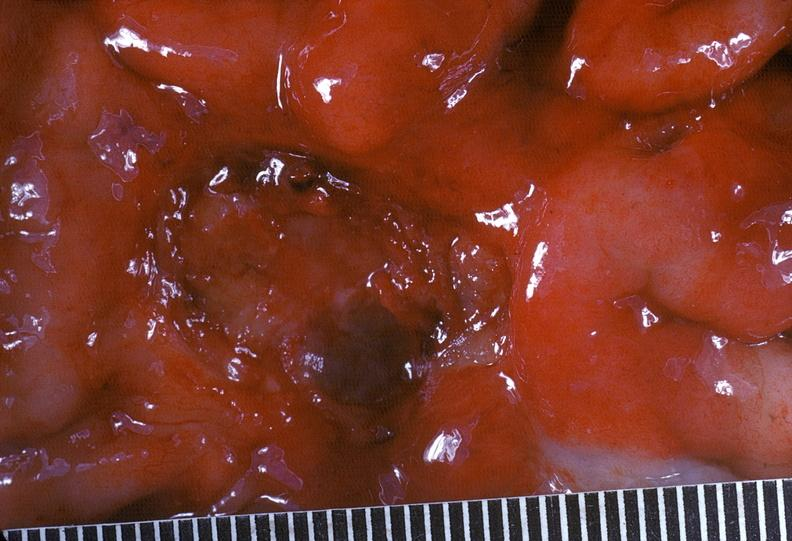what is present?
Answer the question using a single word or phrase. Gastrointestinal 